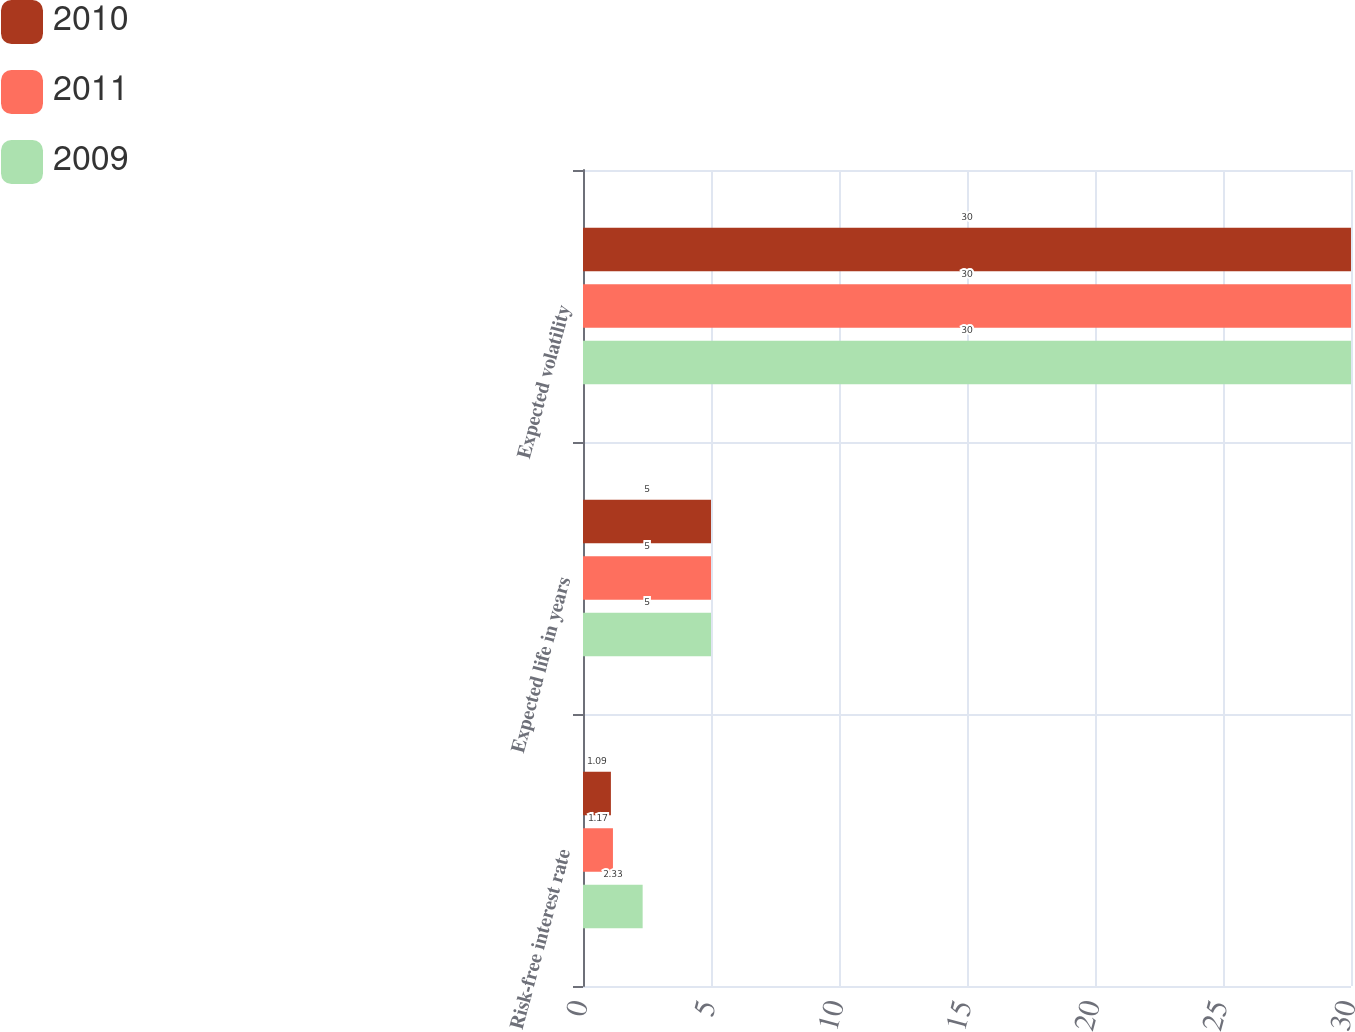Convert chart. <chart><loc_0><loc_0><loc_500><loc_500><stacked_bar_chart><ecel><fcel>Risk-free interest rate<fcel>Expected life in years<fcel>Expected volatility<nl><fcel>2010<fcel>1.09<fcel>5<fcel>30<nl><fcel>2011<fcel>1.17<fcel>5<fcel>30<nl><fcel>2009<fcel>2.33<fcel>5<fcel>30<nl></chart> 